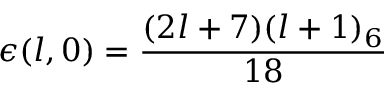<formula> <loc_0><loc_0><loc_500><loc_500>\epsilon ( l , 0 ) = \frac { ( 2 l + 7 ) ( l + 1 ) _ { 6 } } { 1 8 }</formula> 